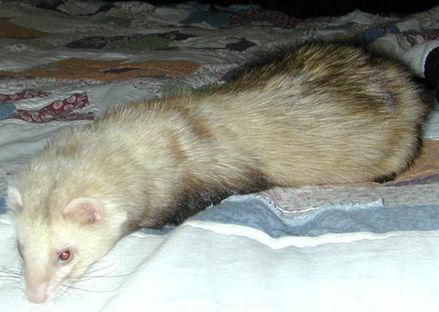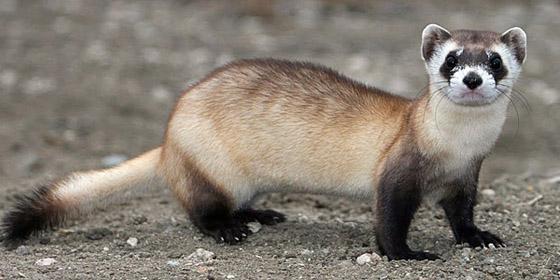The first image is the image on the left, the second image is the image on the right. Examine the images to the left and right. Is the description "An image shows exactly one ferret standing on a dirt ground." accurate? Answer yes or no. Yes. The first image is the image on the left, the second image is the image on the right. Considering the images on both sides, is "There is a ferret in the outdoors looking directly at the camera in the right image." valid? Answer yes or no. Yes. 